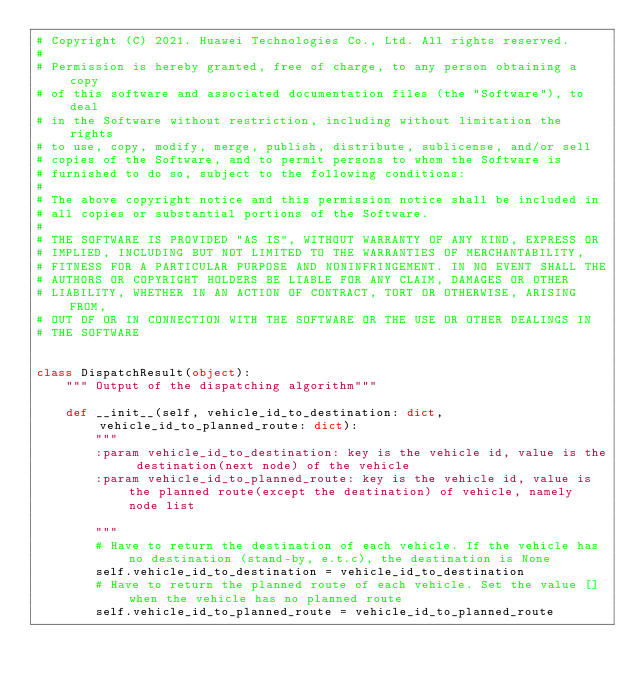Convert code to text. <code><loc_0><loc_0><loc_500><loc_500><_Python_># Copyright (C) 2021. Huawei Technologies Co., Ltd. All rights reserved.
#
# Permission is hereby granted, free of charge, to any person obtaining a copy
# of this software and associated documentation files (the "Software"), to deal
# in the Software without restriction, including without limitation the rights
# to use, copy, modify, merge, publish, distribute, sublicense, and/or sell
# copies of the Software, and to permit persons to whom the Software is
# furnished to do so, subject to the following conditions:
#
# The above copyright notice and this permission notice shall be included in
# all copies or substantial portions of the Software.
#
# THE SOFTWARE IS PROVIDED "AS IS", WITHOUT WARRANTY OF ANY KIND, EXPRESS OR
# IMPLIED, INCLUDING BUT NOT LIMITED TO THE WARRANTIES OF MERCHANTABILITY,
# FITNESS FOR A PARTICULAR PURPOSE AND NONINFRINGEMENT. IN NO EVENT SHALL THE
# AUTHORS OR COPYRIGHT HOLDERS BE LIABLE FOR ANY CLAIM, DAMAGES OR OTHER
# LIABILITY, WHETHER IN AN ACTION OF CONTRACT, TORT OR OTHERWISE, ARISING FROM,
# OUT OF OR IN CONNECTION WITH THE SOFTWARE OR THE USE OR OTHER DEALINGS IN
# THE SOFTWARE


class DispatchResult(object):
    """ Output of the dispatching algorithm"""

    def __init__(self, vehicle_id_to_destination: dict, vehicle_id_to_planned_route: dict):
        """
        :param vehicle_id_to_destination: key is the vehicle id, value is the destination(next node) of the vehicle
        :param vehicle_id_to_planned_route: key is the vehicle id, value is the planned route(except the destination) of vehicle, namely node list

        """
        # Have to return the destination of each vehicle. If the vehicle has no destination (stand-by, e.t.c), the destination is None
        self.vehicle_id_to_destination = vehicle_id_to_destination
        # Have to return the planned route of each vehicle. Set the value [] when the vehicle has no planned route
        self.vehicle_id_to_planned_route = vehicle_id_to_planned_route
</code> 